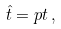Convert formula to latex. <formula><loc_0><loc_0><loc_500><loc_500>\hat { t } = p t \, ,</formula> 